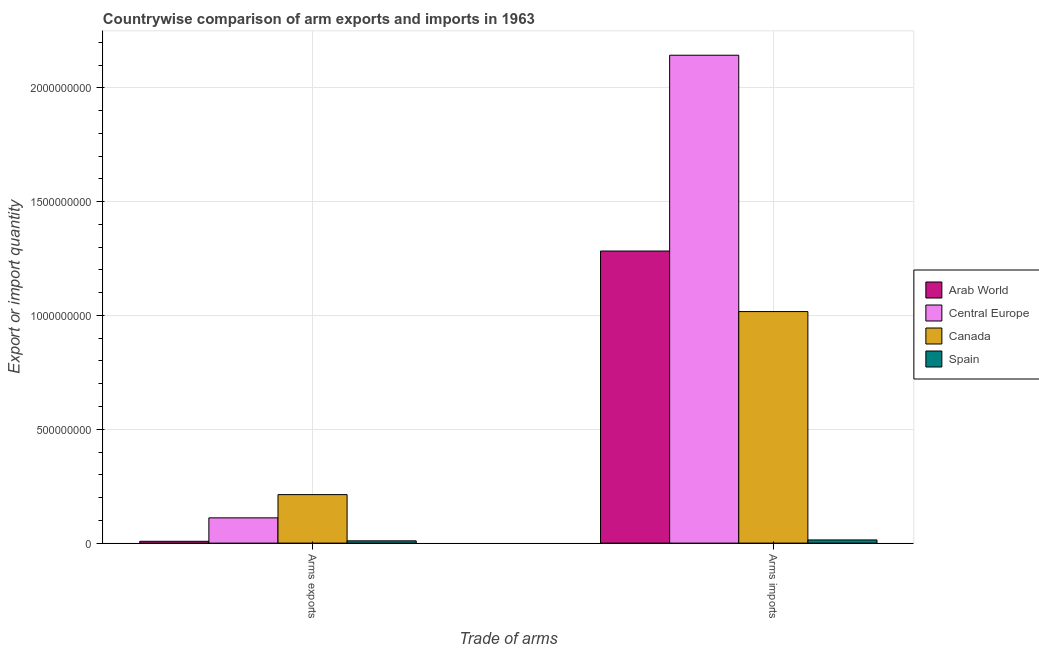Are the number of bars per tick equal to the number of legend labels?
Provide a short and direct response. Yes. Are the number of bars on each tick of the X-axis equal?
Your response must be concise. Yes. How many bars are there on the 1st tick from the left?
Keep it short and to the point. 4. What is the label of the 1st group of bars from the left?
Offer a very short reply. Arms exports. What is the arms imports in Arab World?
Keep it short and to the point. 1.28e+09. Across all countries, what is the maximum arms imports?
Give a very brief answer. 2.14e+09. Across all countries, what is the minimum arms exports?
Keep it short and to the point. 8.00e+06. In which country was the arms exports maximum?
Offer a terse response. Canada. In which country was the arms exports minimum?
Ensure brevity in your answer.  Arab World. What is the total arms exports in the graph?
Your answer should be very brief. 3.42e+08. What is the difference between the arms exports in Central Europe and that in Spain?
Your response must be concise. 1.01e+08. What is the difference between the arms imports in Spain and the arms exports in Central Europe?
Your response must be concise. -9.70e+07. What is the average arms exports per country?
Ensure brevity in your answer.  8.55e+07. What is the difference between the arms imports and arms exports in Central Europe?
Give a very brief answer. 2.03e+09. In how many countries, is the arms exports greater than 600000000 ?
Make the answer very short. 0. What does the 1st bar from the left in Arms exports represents?
Make the answer very short. Arab World. What does the 1st bar from the right in Arms exports represents?
Your answer should be very brief. Spain. How many bars are there?
Give a very brief answer. 8. What is the difference between two consecutive major ticks on the Y-axis?
Your answer should be compact. 5.00e+08. Are the values on the major ticks of Y-axis written in scientific E-notation?
Provide a short and direct response. No. Does the graph contain any zero values?
Offer a very short reply. No. Where does the legend appear in the graph?
Make the answer very short. Center right. What is the title of the graph?
Keep it short and to the point. Countrywise comparison of arm exports and imports in 1963. What is the label or title of the X-axis?
Give a very brief answer. Trade of arms. What is the label or title of the Y-axis?
Offer a very short reply. Export or import quantity. What is the Export or import quantity in Central Europe in Arms exports?
Your response must be concise. 1.11e+08. What is the Export or import quantity in Canada in Arms exports?
Your response must be concise. 2.13e+08. What is the Export or import quantity of Spain in Arms exports?
Make the answer very short. 1.00e+07. What is the Export or import quantity in Arab World in Arms imports?
Offer a very short reply. 1.28e+09. What is the Export or import quantity of Central Europe in Arms imports?
Your answer should be very brief. 2.14e+09. What is the Export or import quantity in Canada in Arms imports?
Offer a very short reply. 1.02e+09. What is the Export or import quantity of Spain in Arms imports?
Your answer should be compact. 1.40e+07. Across all Trade of arms, what is the maximum Export or import quantity in Arab World?
Keep it short and to the point. 1.28e+09. Across all Trade of arms, what is the maximum Export or import quantity in Central Europe?
Your answer should be compact. 2.14e+09. Across all Trade of arms, what is the maximum Export or import quantity in Canada?
Your answer should be compact. 1.02e+09. Across all Trade of arms, what is the maximum Export or import quantity of Spain?
Make the answer very short. 1.40e+07. Across all Trade of arms, what is the minimum Export or import quantity in Arab World?
Keep it short and to the point. 8.00e+06. Across all Trade of arms, what is the minimum Export or import quantity of Central Europe?
Provide a succinct answer. 1.11e+08. Across all Trade of arms, what is the minimum Export or import quantity of Canada?
Keep it short and to the point. 2.13e+08. Across all Trade of arms, what is the minimum Export or import quantity in Spain?
Make the answer very short. 1.00e+07. What is the total Export or import quantity in Arab World in the graph?
Make the answer very short. 1.29e+09. What is the total Export or import quantity in Central Europe in the graph?
Provide a succinct answer. 2.25e+09. What is the total Export or import quantity of Canada in the graph?
Provide a short and direct response. 1.23e+09. What is the total Export or import quantity in Spain in the graph?
Your answer should be compact. 2.40e+07. What is the difference between the Export or import quantity of Arab World in Arms exports and that in Arms imports?
Your answer should be compact. -1.28e+09. What is the difference between the Export or import quantity in Central Europe in Arms exports and that in Arms imports?
Give a very brief answer. -2.03e+09. What is the difference between the Export or import quantity in Canada in Arms exports and that in Arms imports?
Provide a short and direct response. -8.04e+08. What is the difference between the Export or import quantity of Arab World in Arms exports and the Export or import quantity of Central Europe in Arms imports?
Make the answer very short. -2.14e+09. What is the difference between the Export or import quantity of Arab World in Arms exports and the Export or import quantity of Canada in Arms imports?
Keep it short and to the point. -1.01e+09. What is the difference between the Export or import quantity in Arab World in Arms exports and the Export or import quantity in Spain in Arms imports?
Your answer should be very brief. -6.00e+06. What is the difference between the Export or import quantity in Central Europe in Arms exports and the Export or import quantity in Canada in Arms imports?
Give a very brief answer. -9.06e+08. What is the difference between the Export or import quantity of Central Europe in Arms exports and the Export or import quantity of Spain in Arms imports?
Provide a short and direct response. 9.70e+07. What is the difference between the Export or import quantity in Canada in Arms exports and the Export or import quantity in Spain in Arms imports?
Provide a short and direct response. 1.99e+08. What is the average Export or import quantity in Arab World per Trade of arms?
Provide a succinct answer. 6.46e+08. What is the average Export or import quantity in Central Europe per Trade of arms?
Keep it short and to the point. 1.13e+09. What is the average Export or import quantity in Canada per Trade of arms?
Your answer should be very brief. 6.15e+08. What is the difference between the Export or import quantity in Arab World and Export or import quantity in Central Europe in Arms exports?
Offer a very short reply. -1.03e+08. What is the difference between the Export or import quantity in Arab World and Export or import quantity in Canada in Arms exports?
Provide a succinct answer. -2.05e+08. What is the difference between the Export or import quantity of Arab World and Export or import quantity of Spain in Arms exports?
Make the answer very short. -2.00e+06. What is the difference between the Export or import quantity in Central Europe and Export or import quantity in Canada in Arms exports?
Make the answer very short. -1.02e+08. What is the difference between the Export or import quantity in Central Europe and Export or import quantity in Spain in Arms exports?
Offer a very short reply. 1.01e+08. What is the difference between the Export or import quantity of Canada and Export or import quantity of Spain in Arms exports?
Your response must be concise. 2.03e+08. What is the difference between the Export or import quantity in Arab World and Export or import quantity in Central Europe in Arms imports?
Ensure brevity in your answer.  -8.60e+08. What is the difference between the Export or import quantity in Arab World and Export or import quantity in Canada in Arms imports?
Offer a very short reply. 2.66e+08. What is the difference between the Export or import quantity of Arab World and Export or import quantity of Spain in Arms imports?
Offer a terse response. 1.27e+09. What is the difference between the Export or import quantity in Central Europe and Export or import quantity in Canada in Arms imports?
Keep it short and to the point. 1.13e+09. What is the difference between the Export or import quantity in Central Europe and Export or import quantity in Spain in Arms imports?
Give a very brief answer. 2.13e+09. What is the difference between the Export or import quantity in Canada and Export or import quantity in Spain in Arms imports?
Your answer should be compact. 1.00e+09. What is the ratio of the Export or import quantity of Arab World in Arms exports to that in Arms imports?
Provide a succinct answer. 0.01. What is the ratio of the Export or import quantity in Central Europe in Arms exports to that in Arms imports?
Provide a succinct answer. 0.05. What is the ratio of the Export or import quantity in Canada in Arms exports to that in Arms imports?
Make the answer very short. 0.21. What is the difference between the highest and the second highest Export or import quantity of Arab World?
Ensure brevity in your answer.  1.28e+09. What is the difference between the highest and the second highest Export or import quantity in Central Europe?
Keep it short and to the point. 2.03e+09. What is the difference between the highest and the second highest Export or import quantity in Canada?
Your answer should be compact. 8.04e+08. What is the difference between the highest and the lowest Export or import quantity of Arab World?
Your answer should be very brief. 1.28e+09. What is the difference between the highest and the lowest Export or import quantity of Central Europe?
Your answer should be very brief. 2.03e+09. What is the difference between the highest and the lowest Export or import quantity in Canada?
Ensure brevity in your answer.  8.04e+08. 